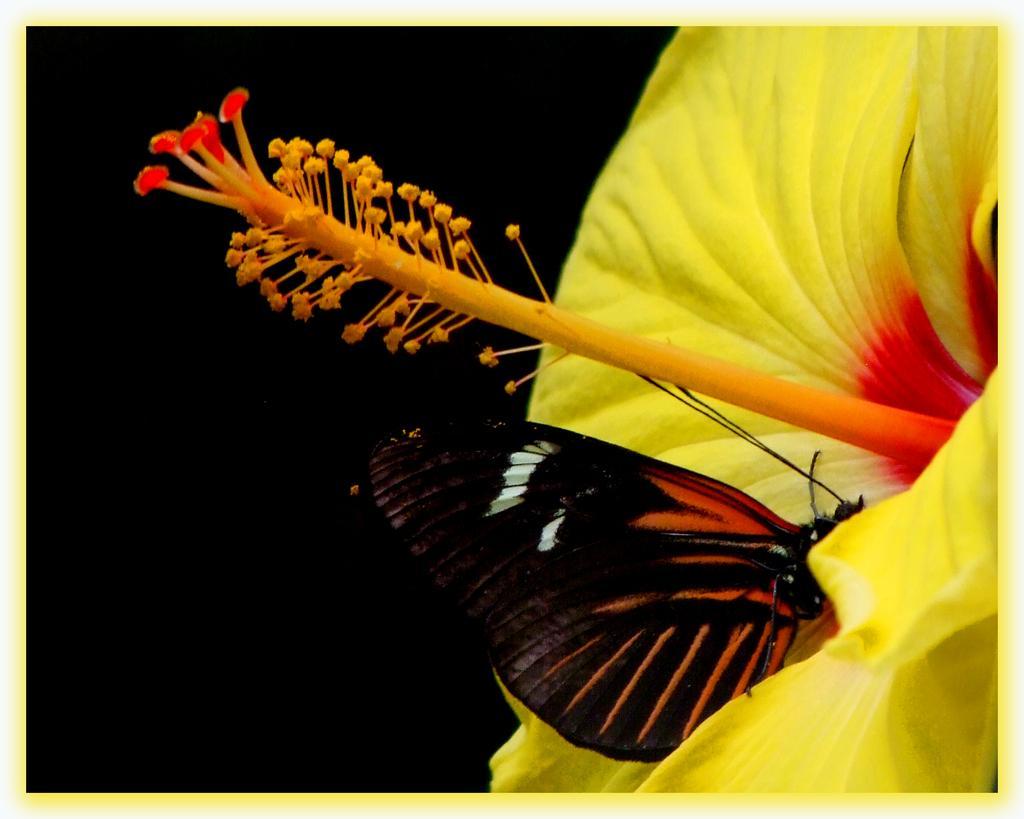In one or two sentences, can you explain what this image depicts? In the picture we can see a photograph with a half part of the flower which is yellow in color with a stigma and stamens to it and on the petal of the flower we can see a butterfly with black color wings and some orange color lines on it. 